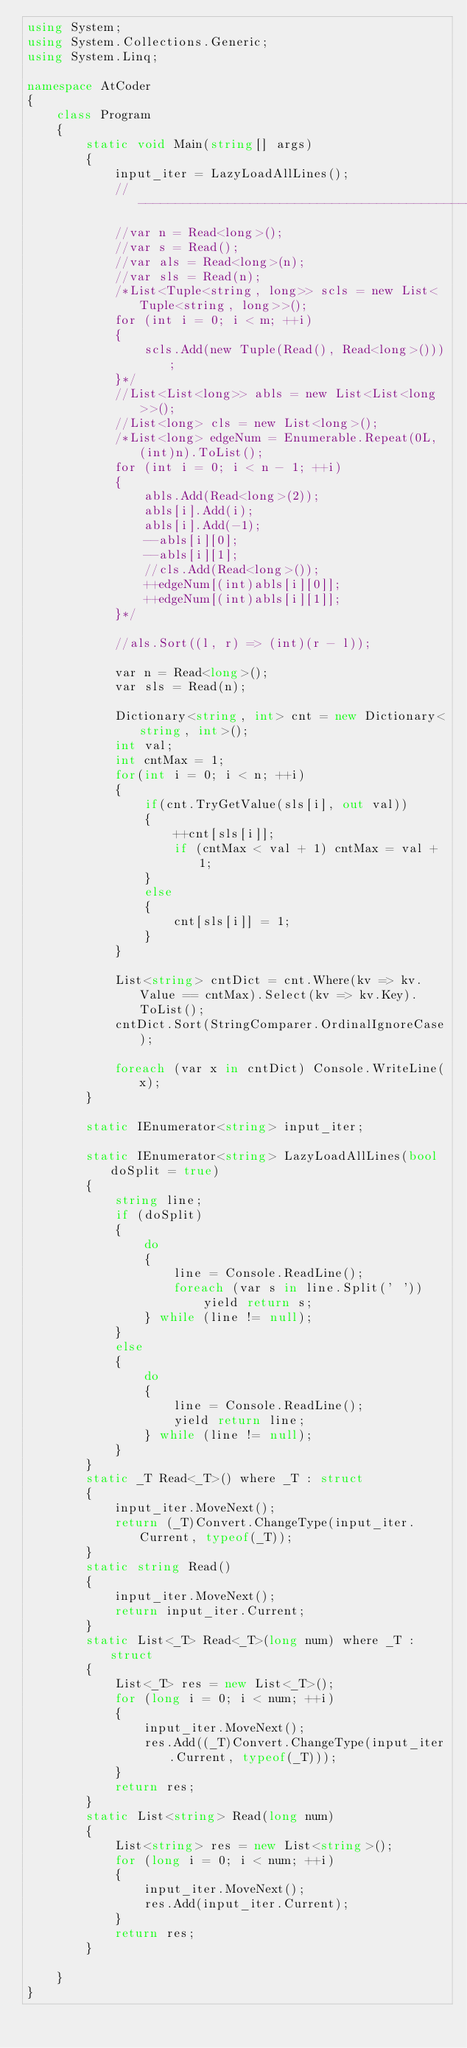<code> <loc_0><loc_0><loc_500><loc_500><_C#_>using System;
using System.Collections.Generic;
using System.Linq;

namespace AtCoder
{
    class Program
    {
        static void Main(string[] args)
        {
            input_iter = LazyLoadAllLines();
            //------------------------------------------------//
            //var n = Read<long>();
            //var s = Read();
            //var als = Read<long>(n);
            //var sls = Read(n);
            /*List<Tuple<string, long>> scls = new List<Tuple<string, long>>();
            for (int i = 0; i < m; ++i)
            {
                scls.Add(new Tuple(Read(), Read<long>()));
            }*/
            //List<List<long>> abls = new List<List<long>>();
            //List<long> cls = new List<long>();
            /*List<long> edgeNum = Enumerable.Repeat(0L, (int)n).ToList();
            for (int i = 0; i < n - 1; ++i)
            {
                abls.Add(Read<long>(2));
                abls[i].Add(i);
                abls[i].Add(-1);
                --abls[i][0];
                --abls[i][1];
                //cls.Add(Read<long>());
                ++edgeNum[(int)abls[i][0]];
                ++edgeNum[(int)abls[i][1]];
            }*/

            //als.Sort((l, r) => (int)(r - l));

            var n = Read<long>();
            var sls = Read(n);

            Dictionary<string, int> cnt = new Dictionary<string, int>();
            int val;
            int cntMax = 1;
            for(int i = 0; i < n; ++i)
            {
                if(cnt.TryGetValue(sls[i], out val))
                {
                    ++cnt[sls[i]];
                    if (cntMax < val + 1) cntMax = val + 1;
                }
                else
                {
                    cnt[sls[i]] = 1;
                }
            }

            List<string> cntDict = cnt.Where(kv => kv.Value == cntMax).Select(kv => kv.Key).ToList();
            cntDict.Sort(StringComparer.OrdinalIgnoreCase);

            foreach (var x in cntDict) Console.WriteLine(x);
        }

        static IEnumerator<string> input_iter;

        static IEnumerator<string> LazyLoadAllLines(bool doSplit = true)
        {
            string line;
            if (doSplit)
            {
                do
                {
                    line = Console.ReadLine();
                    foreach (var s in line.Split(' '))
                        yield return s;
                } while (line != null);
            }
            else
            {
                do
                {
                    line = Console.ReadLine();
                    yield return line;
                } while (line != null);
            }
        }
        static _T Read<_T>() where _T : struct
        {
            input_iter.MoveNext();
            return (_T)Convert.ChangeType(input_iter.Current, typeof(_T));
        }
        static string Read()
        {
            input_iter.MoveNext();
            return input_iter.Current;
        }
        static List<_T> Read<_T>(long num) where _T : struct
        {
            List<_T> res = new List<_T>();
            for (long i = 0; i < num; ++i)
            {
                input_iter.MoveNext();
                res.Add((_T)Convert.ChangeType(input_iter.Current, typeof(_T)));
            }
            return res;
        }
        static List<string> Read(long num)
        {
            List<string> res = new List<string>();
            for (long i = 0; i < num; ++i)
            {
                input_iter.MoveNext();
                res.Add(input_iter.Current);
            }
            return res;
        }

    }
}
</code> 